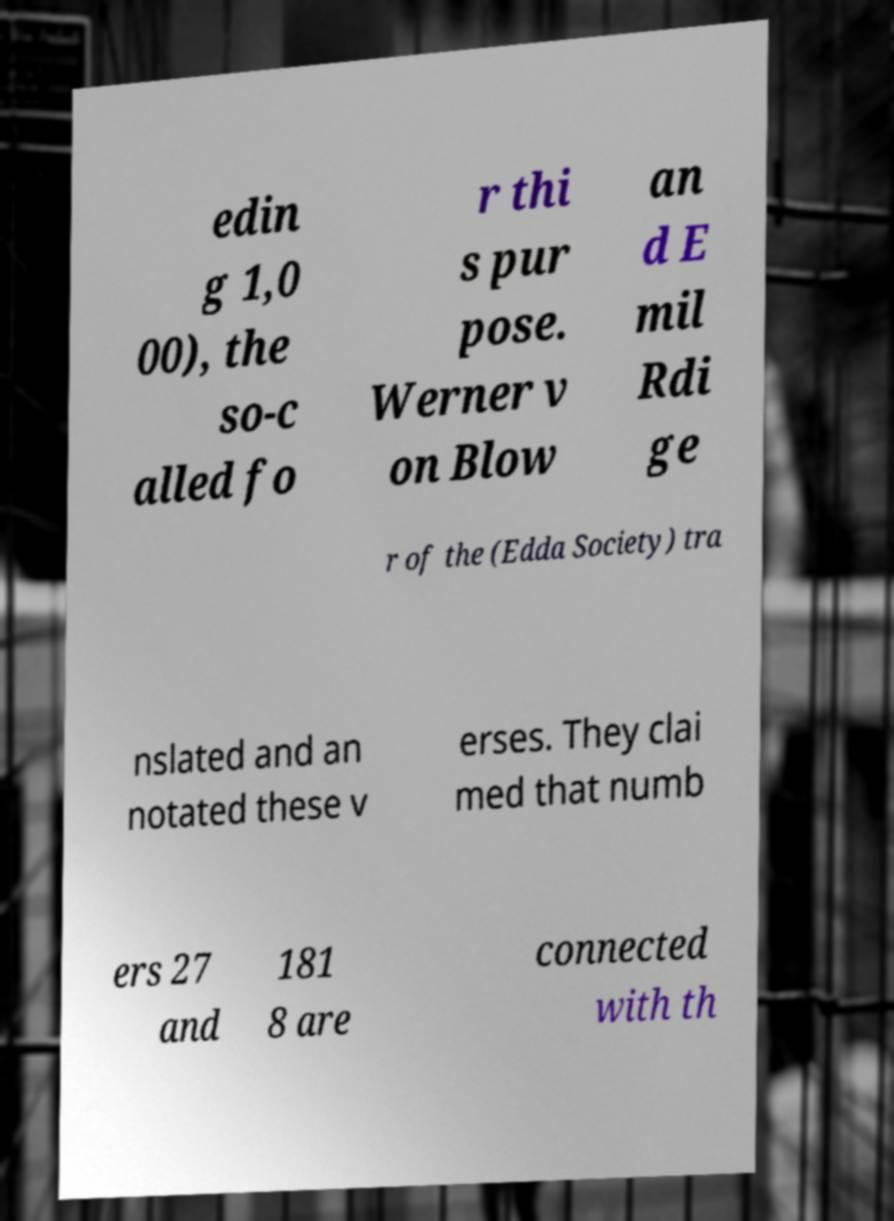There's text embedded in this image that I need extracted. Can you transcribe it verbatim? edin g 1,0 00), the so-c alled fo r thi s pur pose. Werner v on Blow an d E mil Rdi ge r of the (Edda Society) tra nslated and an notated these v erses. They clai med that numb ers 27 and 181 8 are connected with th 